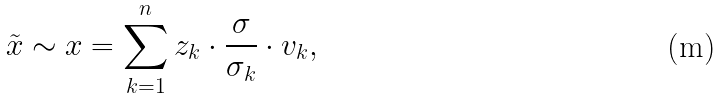Convert formula to latex. <formula><loc_0><loc_0><loc_500><loc_500>\tilde { x } \sim x = \sum _ { k = 1 } ^ { n } z _ { k } \cdot \frac { \sigma } { \sigma _ { k } } \cdot v _ { k } ,</formula> 